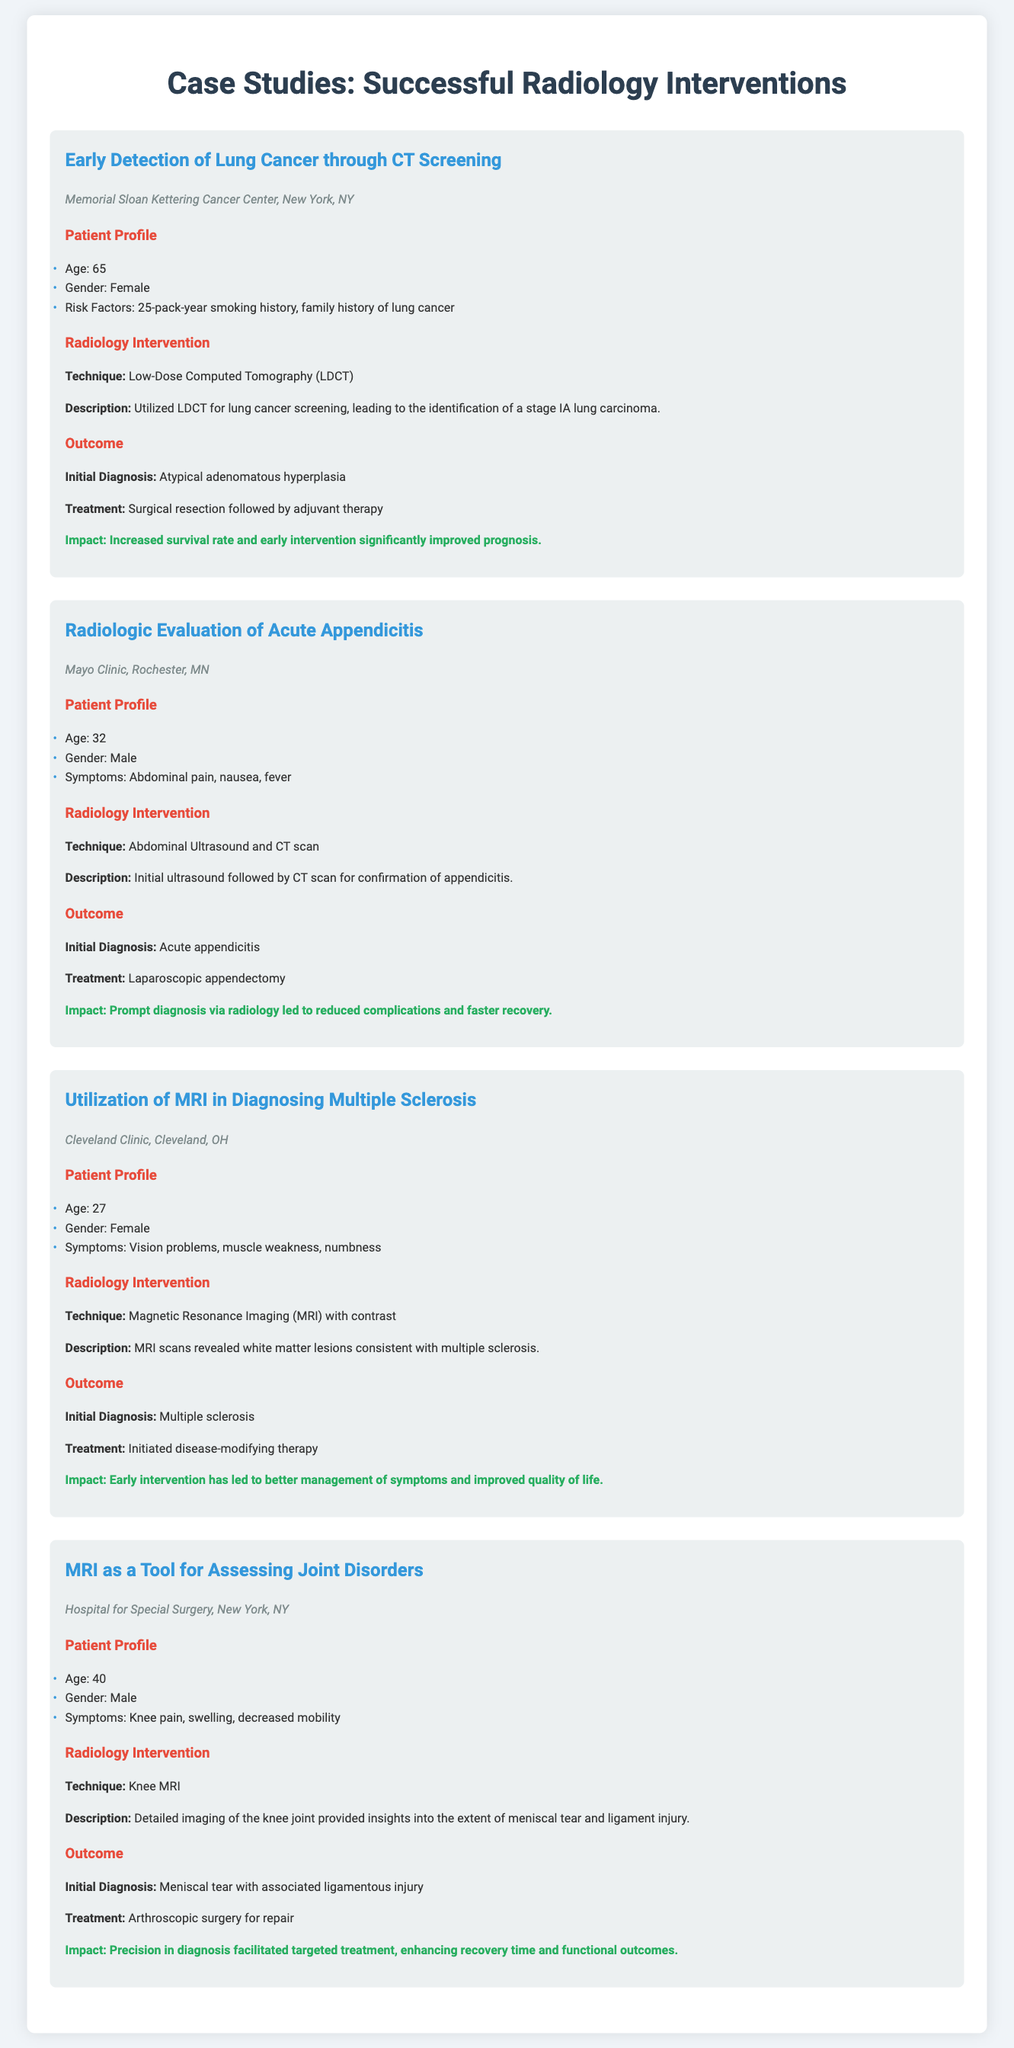What is the title of the first case study? The title is clearly mentioned at the beginning of each case study section. The first case study is about the early detection of lung cancer.
Answer: Early Detection of Lung Cancer through CT Screening What is the age of the male patient in the second case study? The patient's age is specified in the patient profile section of the case study, particularly for the acute appendicitis case.
Answer: 32 What technique was used for the radiology intervention in the case study about multiple sclerosis? The intervention technique is listed under the radiology intervention section for each case study, and for multiple sclerosis, it is MRI.
Answer: Magnetic Resonance Imaging (MRI) with contrast What was the impact of the intervention for the case on acute appendicitis? The impact is summarized at the end of each outcome section and indicates the overall result of the intervention in terms of patient care.
Answer: Reduced complications and faster recovery What treatment was initiated for the female patient diagnosed with multiple sclerosis? The treatment for each patient is specified in the outcome section, where it details the medical approach taken after diagnosis.
Answer: Disease-modifying therapy 